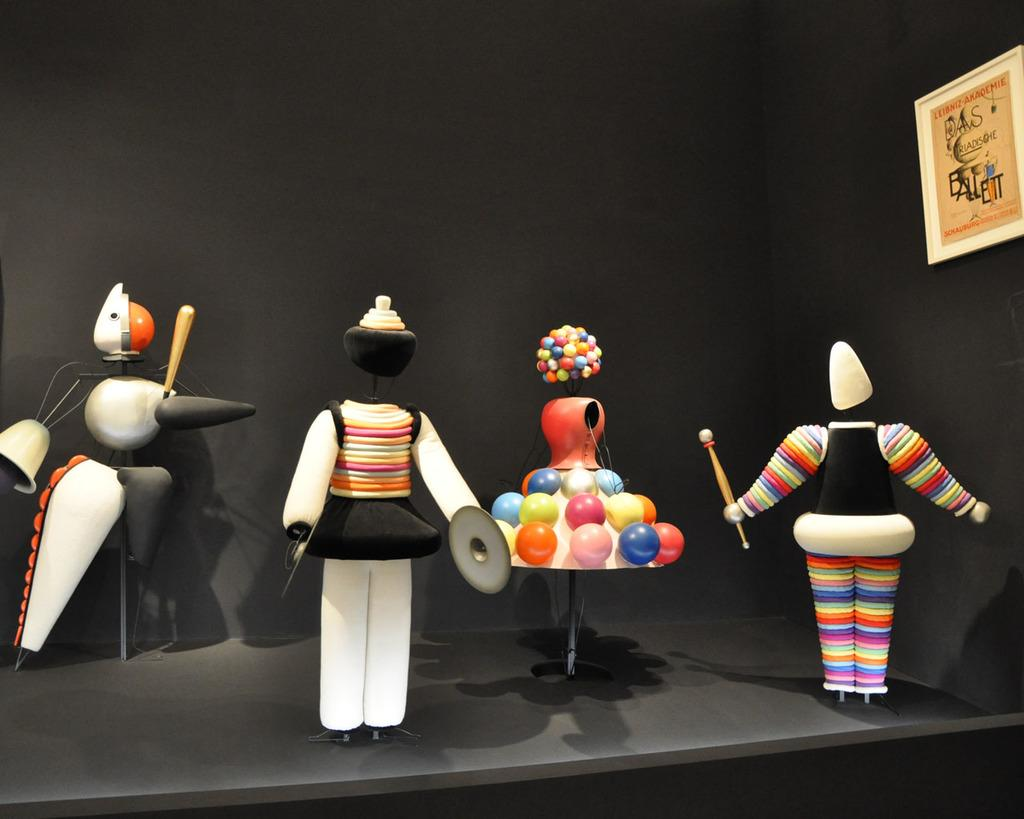What objects are on the table in the image? There are figurines on the table in the image. What can be seen on the right side of the image? There is a board on the right side of the image. Can you see an airplane flying over the seashore in the image? There is no airplane or seashore present in the image. How many chairs are visible in the image? There is no chair present in the image. 